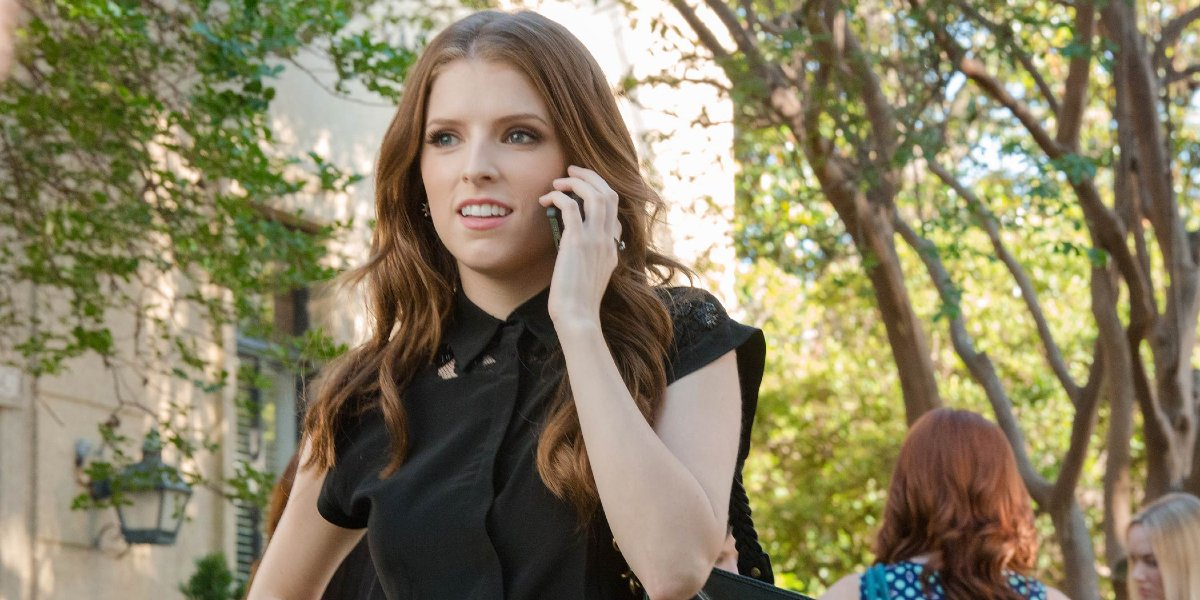What does her body language tell us about the conversation? Her body language, with a hand holding the phone to her ear and her attentive gaze, indicates that she is deeply engaged in the conversation. The slight crease in her brow suggests that the discussion could be of a serious or concerning nature. 